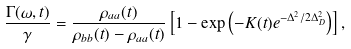<formula> <loc_0><loc_0><loc_500><loc_500>\frac { \Gamma ( \omega , t ) } { \gamma } = \frac { \rho _ { a a } ( t ) } { \rho _ { b b } ( t ) - \rho _ { a a } ( t ) } \left [ 1 - \exp \left ( - K ( t ) e ^ { - \Delta ^ { 2 } / 2 \Delta _ { D } ^ { 2 } } \right ) \right ] ,</formula> 